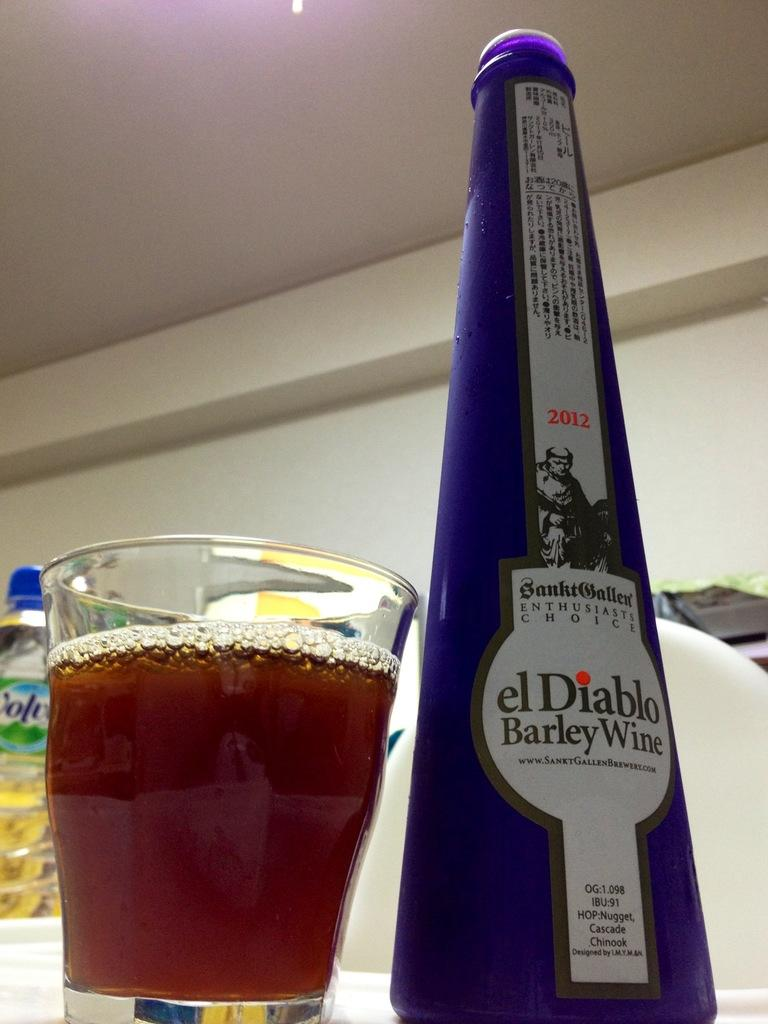Provide a one-sentence caption for the provided image. A tall bottle of el Diablo barley wine next to a mostly full glass. 